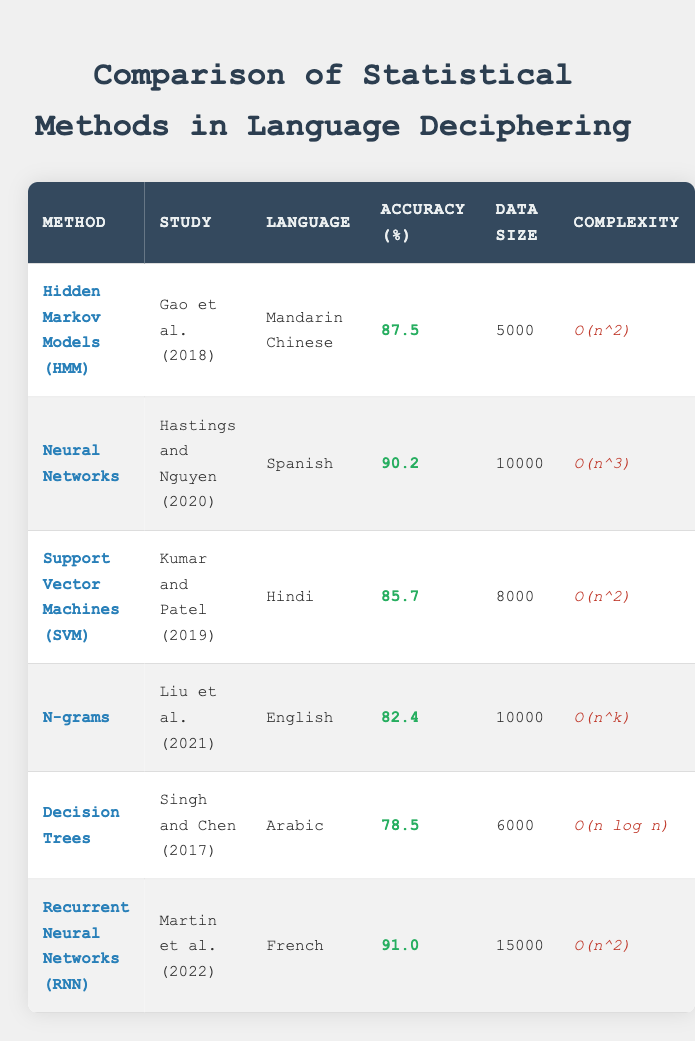What statistical method had the highest accuracy? By reviewing the accuracy values listed in the table, we find that Recurrent Neural Networks (RNN) has the highest accuracy at 91.0 percent.
Answer: 91.0 percent Which study used the largest data size? The table shows that the study by Martin et al. (2022) on Recurrent Neural Networks had a data size of 15,000, which is the largest among all listed studies.
Answer: 15,000 What is the average accuracy of the methods used across all studies? The accuracy values are 87.5, 90.2, 85.7, 82.4, 78.5, and 91.0. Adding these gives a total of 515.3. There are 6 methods, so the average accuracy is 515.3 / 6 = 85.8833, rounded to approximately 85.9.
Answer: 85.9 Is the complexity of Neural Networks higher than that of Support Vector Machines? The table lists the complexity of Neural Networks as O(n^3) and that of Support Vector Machines as O(n^2). Since O(n^3) grows faster with increasing n than O(n^2), the answer is yes.
Answer: Yes Which two methods have the same complexity order? We can see that both Hidden Markov Models and Support Vector Machines have a complexity order of O(n^2). Therefore, the two methods with the same complexity order are Hidden Markov Models and Support Vector Machines.
Answer: Hidden Markov Models, Support Vector Machines What method has the lowest accuracy, and which language does it pertain to? Upon examining the accuracy values, we see that Decision Trees has the lowest accuracy at 78.5 percent, and it pertains to Arabic.
Answer: Decision Trees, Arabic 